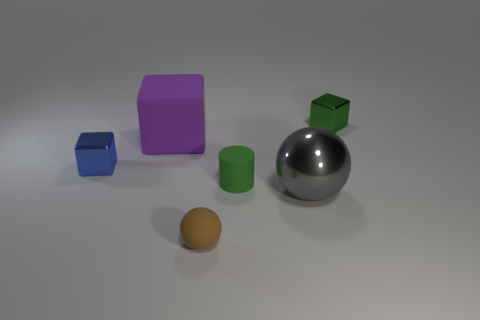Is there any other thing that is made of the same material as the purple cube?
Ensure brevity in your answer.  Yes. What number of things are both in front of the gray thing and behind the gray shiny object?
Keep it short and to the point. 0. What color is the metallic cube that is on the left side of the tiny shiny cube behind the blue metal thing?
Offer a terse response. Blue. Is the number of large purple rubber cubes right of the matte block the same as the number of tiny gray metal blocks?
Ensure brevity in your answer.  Yes. There is a matte thing that is behind the small green object that is left of the green cube; how many green matte objects are in front of it?
Provide a short and direct response. 1. There is a small metal object to the right of the metallic sphere; what color is it?
Provide a succinct answer. Green. What is the material of the object that is both behind the tiny blue shiny thing and to the right of the purple matte thing?
Your answer should be very brief. Metal. What number of gray spheres are to the left of the tiny thing behind the blue object?
Make the answer very short. 1. What shape is the large purple rubber thing?
Make the answer very short. Cube. What shape is the big object that is the same material as the tiny sphere?
Provide a succinct answer. Cube. 